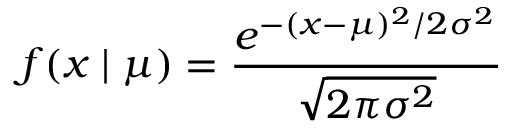<formula> <loc_0><loc_0><loc_500><loc_500>f ( x | \mu ) = { \frac { e ^ { - ( x - \mu ) ^ { 2 } / 2 \sigma ^ { 2 } } } { \sqrt { 2 \pi \sigma ^ { 2 } } } }</formula> 